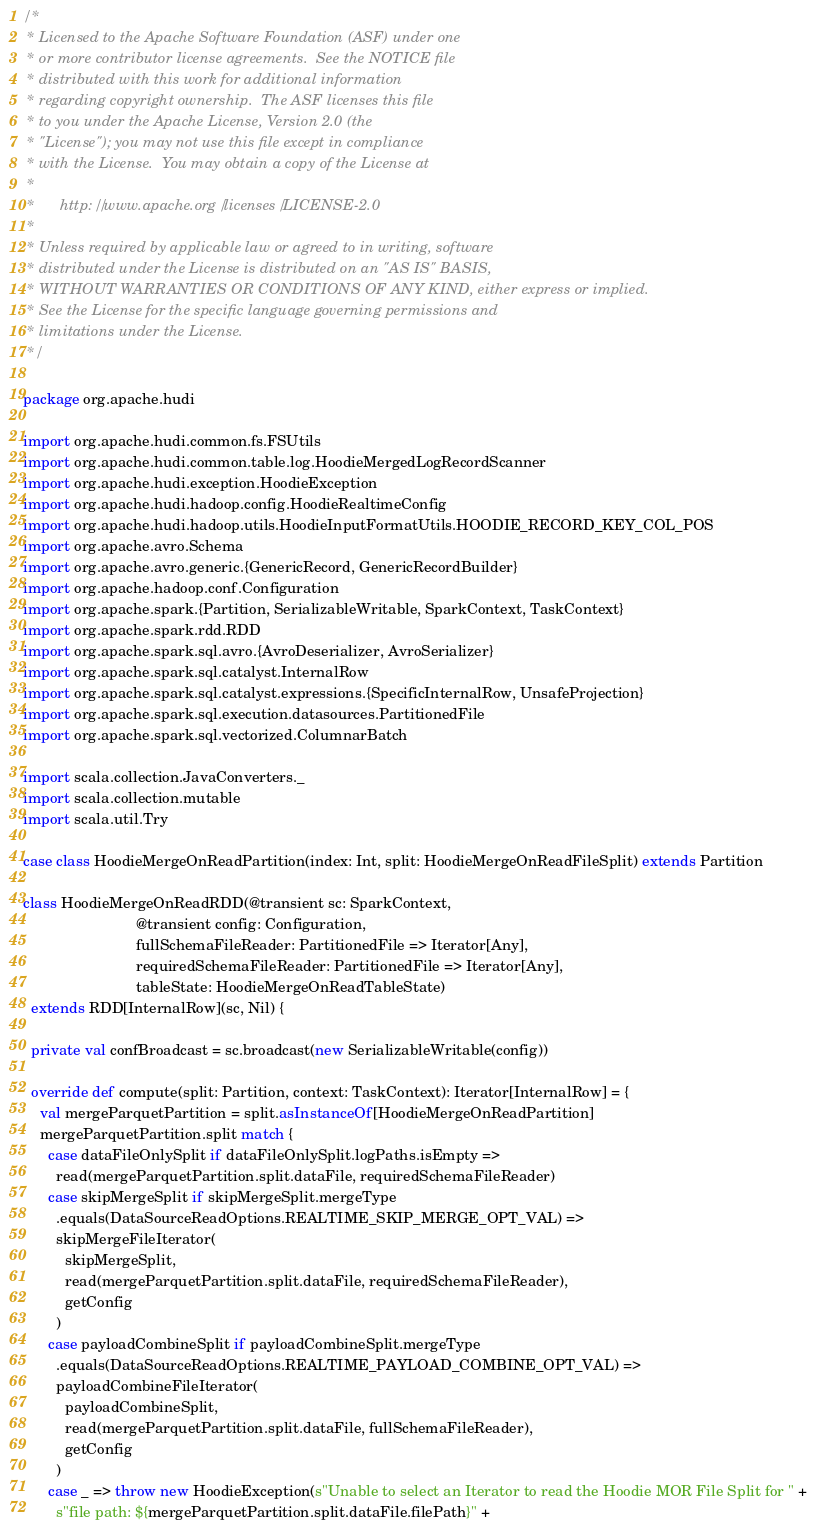<code> <loc_0><loc_0><loc_500><loc_500><_Scala_>/*
 * Licensed to the Apache Software Foundation (ASF) under one
 * or more contributor license agreements.  See the NOTICE file
 * distributed with this work for additional information
 * regarding copyright ownership.  The ASF licenses this file
 * to you under the Apache License, Version 2.0 (the
 * "License"); you may not use this file except in compliance
 * with the License.  You may obtain a copy of the License at
 *
 *      http://www.apache.org/licenses/LICENSE-2.0
 *
 * Unless required by applicable law or agreed to in writing, software
 * distributed under the License is distributed on an "AS IS" BASIS,
 * WITHOUT WARRANTIES OR CONDITIONS OF ANY KIND, either express or implied.
 * See the License for the specific language governing permissions and
 * limitations under the License.
 */

package org.apache.hudi

import org.apache.hudi.common.fs.FSUtils
import org.apache.hudi.common.table.log.HoodieMergedLogRecordScanner
import org.apache.hudi.exception.HoodieException
import org.apache.hudi.hadoop.config.HoodieRealtimeConfig
import org.apache.hudi.hadoop.utils.HoodieInputFormatUtils.HOODIE_RECORD_KEY_COL_POS
import org.apache.avro.Schema
import org.apache.avro.generic.{GenericRecord, GenericRecordBuilder}
import org.apache.hadoop.conf.Configuration
import org.apache.spark.{Partition, SerializableWritable, SparkContext, TaskContext}
import org.apache.spark.rdd.RDD
import org.apache.spark.sql.avro.{AvroDeserializer, AvroSerializer}
import org.apache.spark.sql.catalyst.InternalRow
import org.apache.spark.sql.catalyst.expressions.{SpecificInternalRow, UnsafeProjection}
import org.apache.spark.sql.execution.datasources.PartitionedFile
import org.apache.spark.sql.vectorized.ColumnarBatch

import scala.collection.JavaConverters._
import scala.collection.mutable
import scala.util.Try

case class HoodieMergeOnReadPartition(index: Int, split: HoodieMergeOnReadFileSplit) extends Partition

class HoodieMergeOnReadRDD(@transient sc: SparkContext,
                           @transient config: Configuration,
                           fullSchemaFileReader: PartitionedFile => Iterator[Any],
                           requiredSchemaFileReader: PartitionedFile => Iterator[Any],
                           tableState: HoodieMergeOnReadTableState)
  extends RDD[InternalRow](sc, Nil) {

  private val confBroadcast = sc.broadcast(new SerializableWritable(config))

  override def compute(split: Partition, context: TaskContext): Iterator[InternalRow] = {
    val mergeParquetPartition = split.asInstanceOf[HoodieMergeOnReadPartition]
    mergeParquetPartition.split match {
      case dataFileOnlySplit if dataFileOnlySplit.logPaths.isEmpty =>
        read(mergeParquetPartition.split.dataFile, requiredSchemaFileReader)
      case skipMergeSplit if skipMergeSplit.mergeType
        .equals(DataSourceReadOptions.REALTIME_SKIP_MERGE_OPT_VAL) =>
        skipMergeFileIterator(
          skipMergeSplit,
          read(mergeParquetPartition.split.dataFile, requiredSchemaFileReader),
          getConfig
        )
      case payloadCombineSplit if payloadCombineSplit.mergeType
        .equals(DataSourceReadOptions.REALTIME_PAYLOAD_COMBINE_OPT_VAL) =>
        payloadCombineFileIterator(
          payloadCombineSplit,
          read(mergeParquetPartition.split.dataFile, fullSchemaFileReader),
          getConfig
        )
      case _ => throw new HoodieException(s"Unable to select an Iterator to read the Hoodie MOR File Split for " +
        s"file path: ${mergeParquetPartition.split.dataFile.filePath}" +</code> 